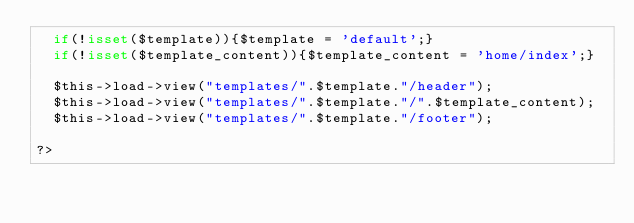Convert code to text. <code><loc_0><loc_0><loc_500><loc_500><_PHP_>  if(!isset($template)){$template = 'default';}
  if(!isset($template_content)){$template_content = 'home/index';}

  $this->load->view("templates/".$template."/header");
  $this->load->view("templates/".$template."/".$template_content);
  $this->load->view("templates/".$template."/footer");

?>
</code> 